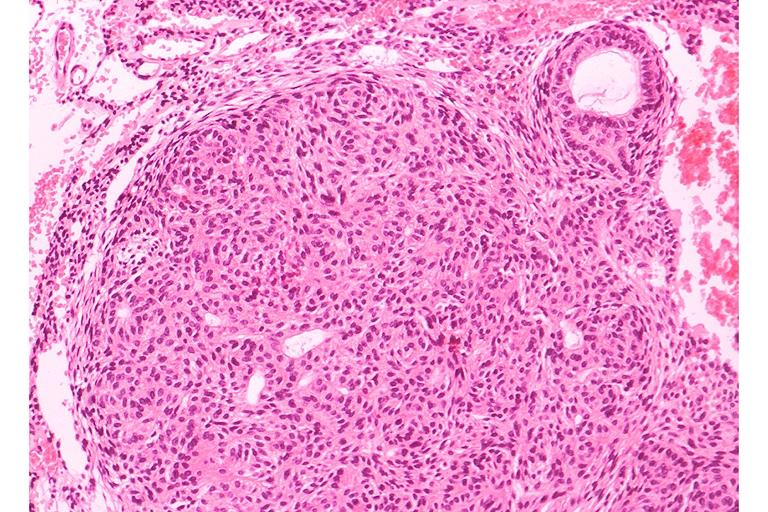s oral present?
Answer the question using a single word or phrase. Yes 